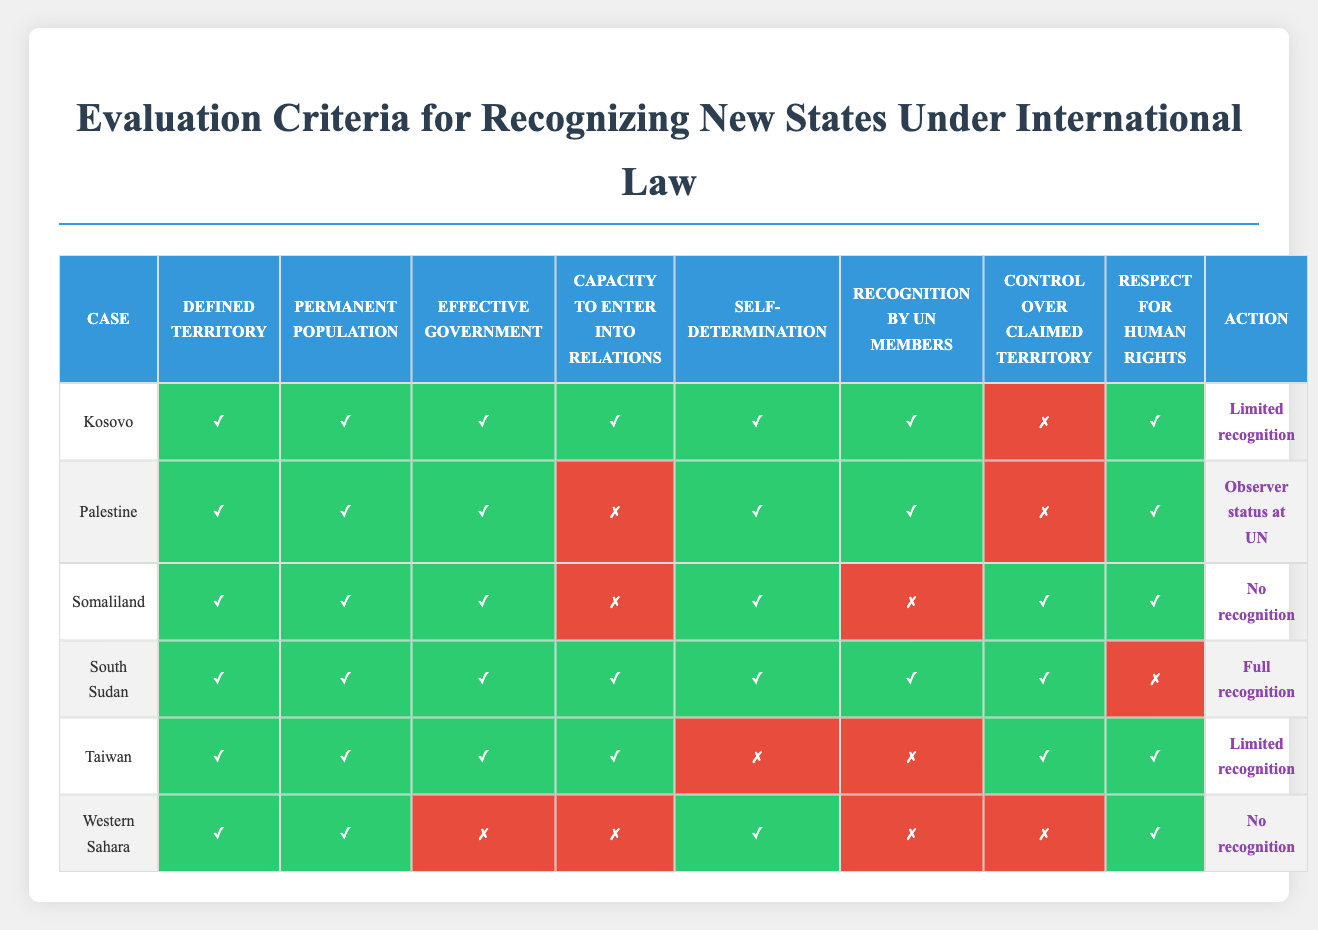What is the action taken for Kosovo? The table shows that Kosovo is marked with "Limited recognition" in the action column.
Answer: Limited recognition Does Palestine have an effective government? In the table, the condition for "Effective government" for Palestine is marked as false (✗), indicating it does not meet this criterion.
Answer: No Which state has full recognition? The table highlights that South Sudan is the only state with "Full recognition" under the action column.
Answer: South Sudan How many states do not receive any recognition? By examining the action column in the table, we note that Somaliland and Western Sahara both receive "No recognition," which totals to 2 states.
Answer: 2 What are the conditions for Taiwan's recognition? Taiwan has the following conditions met: Defined territory (✓), Permanent population (✓), Effective government (✓), Capacity to enter into relations (✓), Self-determination (✗), Recognition by UN members (✗), Control over claimed territory (✓), and Respect for human rights (✓). It meets most conditions but fails in self-determination and UN recognition.
Answer: Meets 6 conditions Which two cases have control over claimed territory marked as true? By reviewing the table, South Sudan and Somaliland both have "Control over claimed territory" marked as true (✓), revealing these two cases meet this particular condition.
Answer: South Sudan, Somaliland Is there any case that has recognition by UN member states marked as true and receives full recognition? The table shows that South Sudan, which has recognition by UN member states marked as true (✓), also receives "Full recognition." Thus, there is indeed such a case.
Answer: Yes What is the difference in the number of criteria met between South Sudan and Palestine? South Sudan meets 7 out of 8 criteria as marked in the table, while Palestine meets 5 out of 8. The difference is therefore 7 - 5 = 2 criteria more for South Sudan.
Answer: 2 Which state has the lowest level of recognition? By closely examining the table, it is evident that Somaliland has "No recognition," making it the state with the lowest level of recognition among those listed.
Answer: Somaliland Is respect for human rights a condition for full recognition? The table indicates that for South Sudan, despite meeting all other criteria, "Respect for human rights" is marked as false (✗). This implies it does not have to be fully met to receive full recognition.
Answer: No 